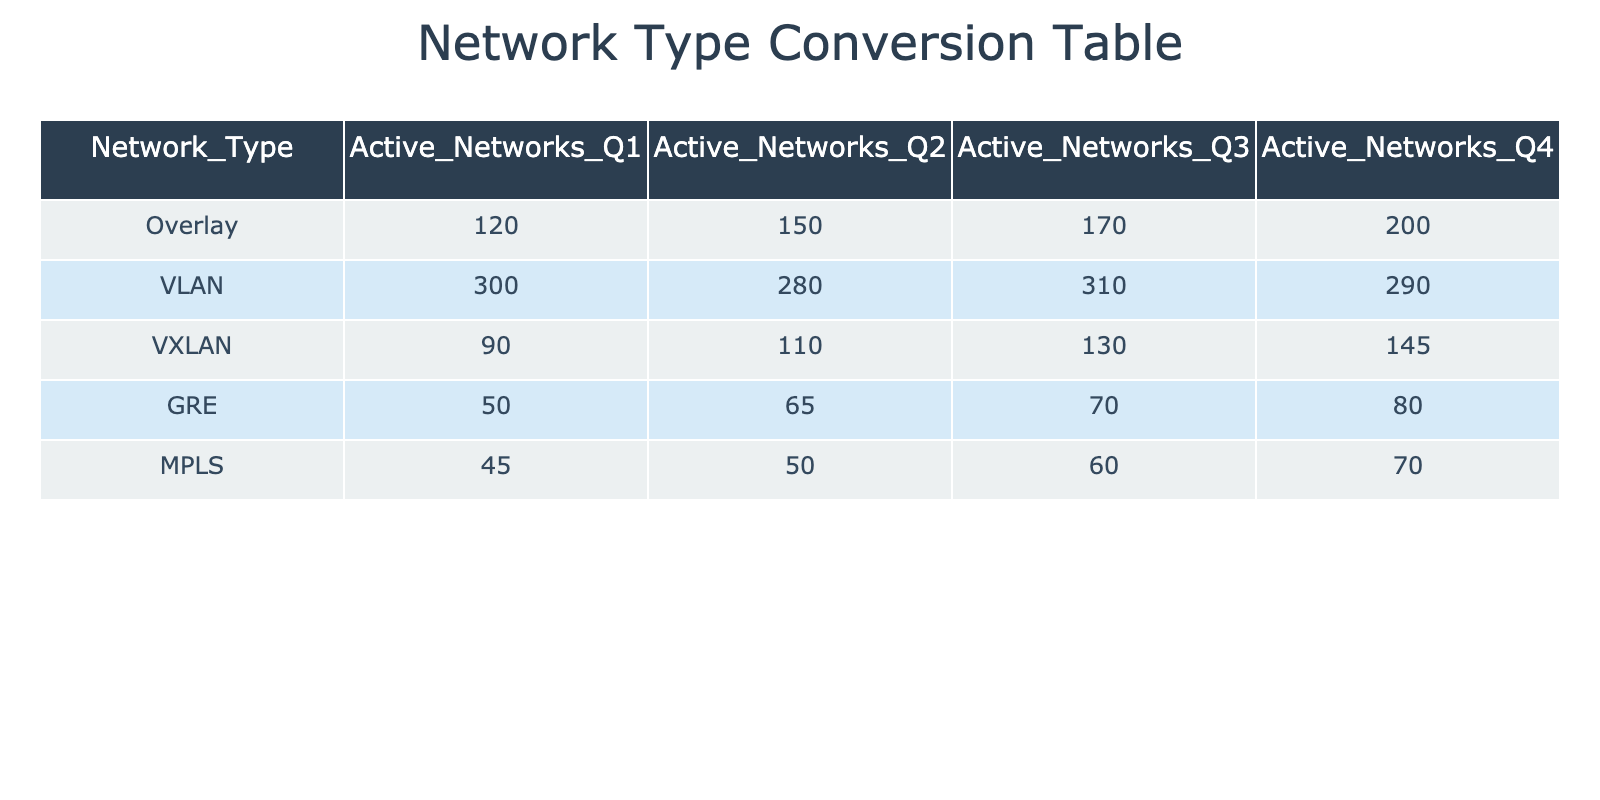What is the number of active overlay networks in Q1? According to the table, in Q1, the number of active overlay networks is listed directly under the "Active_Networks_Q1" column for the "Overlay" row. The value is 120.
Answer: 120 Which network type had the least number of active networks in Q4? To find the network type with the least number of active networks in Q4, we look at the "Active_Networks_Q4" column and identify the smallest value among all network types. The values are: Overlay (200), VLAN (290), VXLAN (145), GRE (80), and MPLS (70). The minimum is 70 for MPLS.
Answer: MPLS What is the total number of active VLAN and MPLS networks in Q2? We first find the values in Q2 for VLAN and MPLS from their respective rows: VLAN has 280 and MPLS has 50. Next, we sum these two values: 280 + 50 = 330.
Answer: 330 Did the number of active VXLAN networks increase every quarter? To determine if the number of active VXLAN networks increased every quarter, we check the values for VXLAN across all quarters: Q1 (90), Q2 (110), Q3 (130), and Q4 (145). The values are consistently increasing, indicating that there is no decrease in any quarter. Therefore, the answer is yes.
Answer: Yes What is the average number of active GRE networks over all quarters? We first identify the number of active GRE networks for each quarter: Q1 (50), Q2 (65), Q3 (70), and Q4 (80). We add these values together: 50 + 65 + 70 + 80 = 265. Next, we divide this sum by the number of quarters (4) to find the average: 265 / 4 = 66.25.
Answer: 66.25 